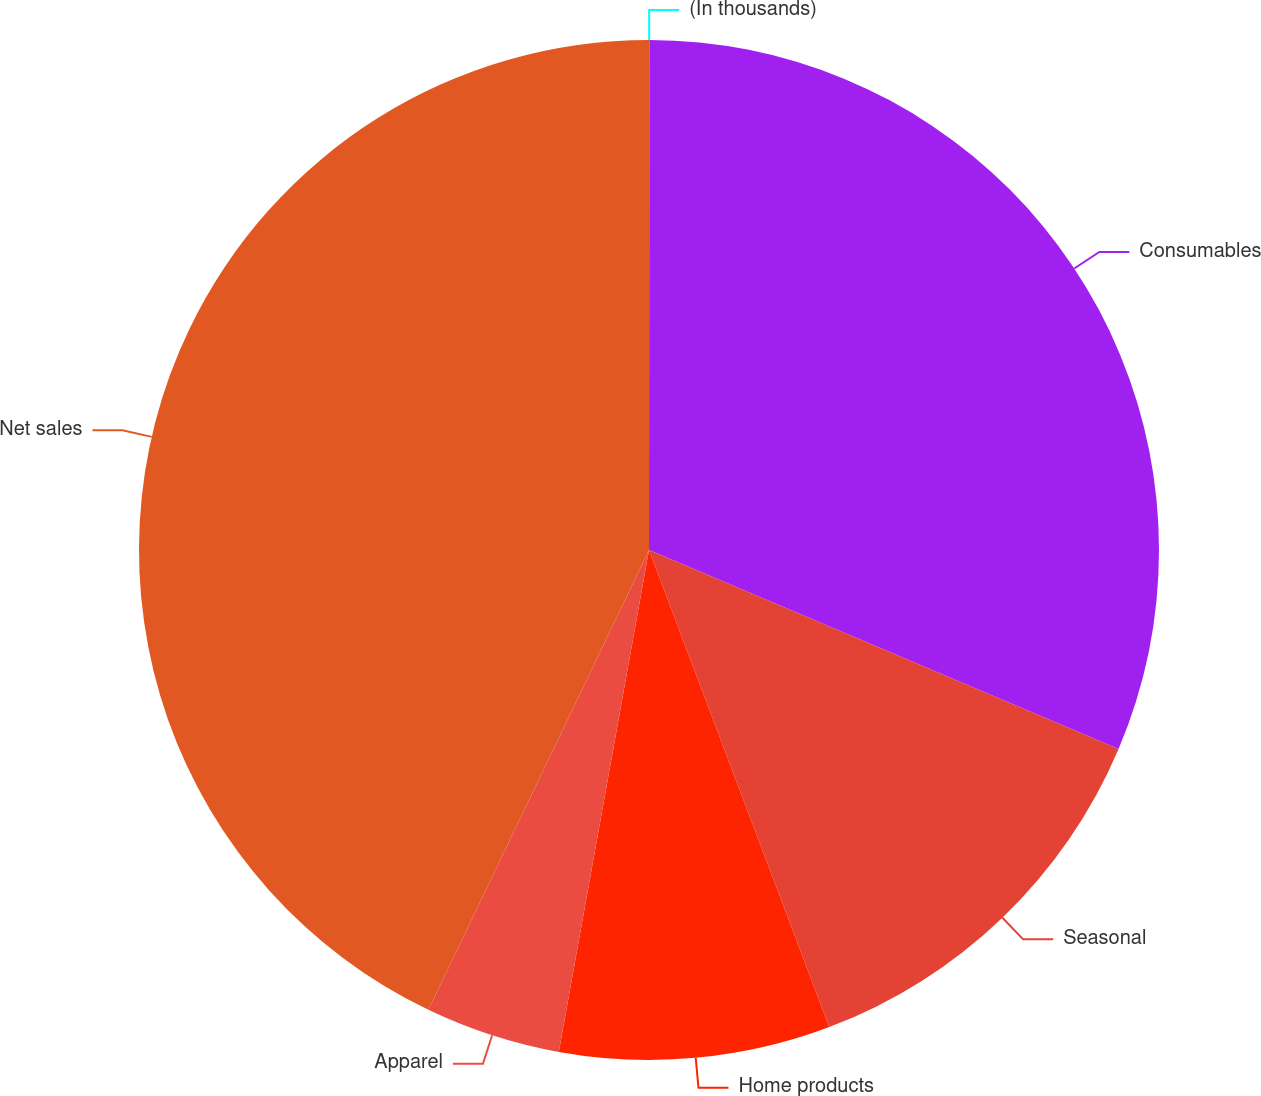<chart> <loc_0><loc_0><loc_500><loc_500><pie_chart><fcel>(In thousands)<fcel>Consumables<fcel>Seasonal<fcel>Home products<fcel>Apparel<fcel>Net sales<nl><fcel>0.01%<fcel>31.37%<fcel>12.87%<fcel>8.58%<fcel>4.29%<fcel>42.88%<nl></chart> 